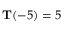<formula> <loc_0><loc_0><loc_500><loc_500>T ( - 5 ) = 5</formula> 